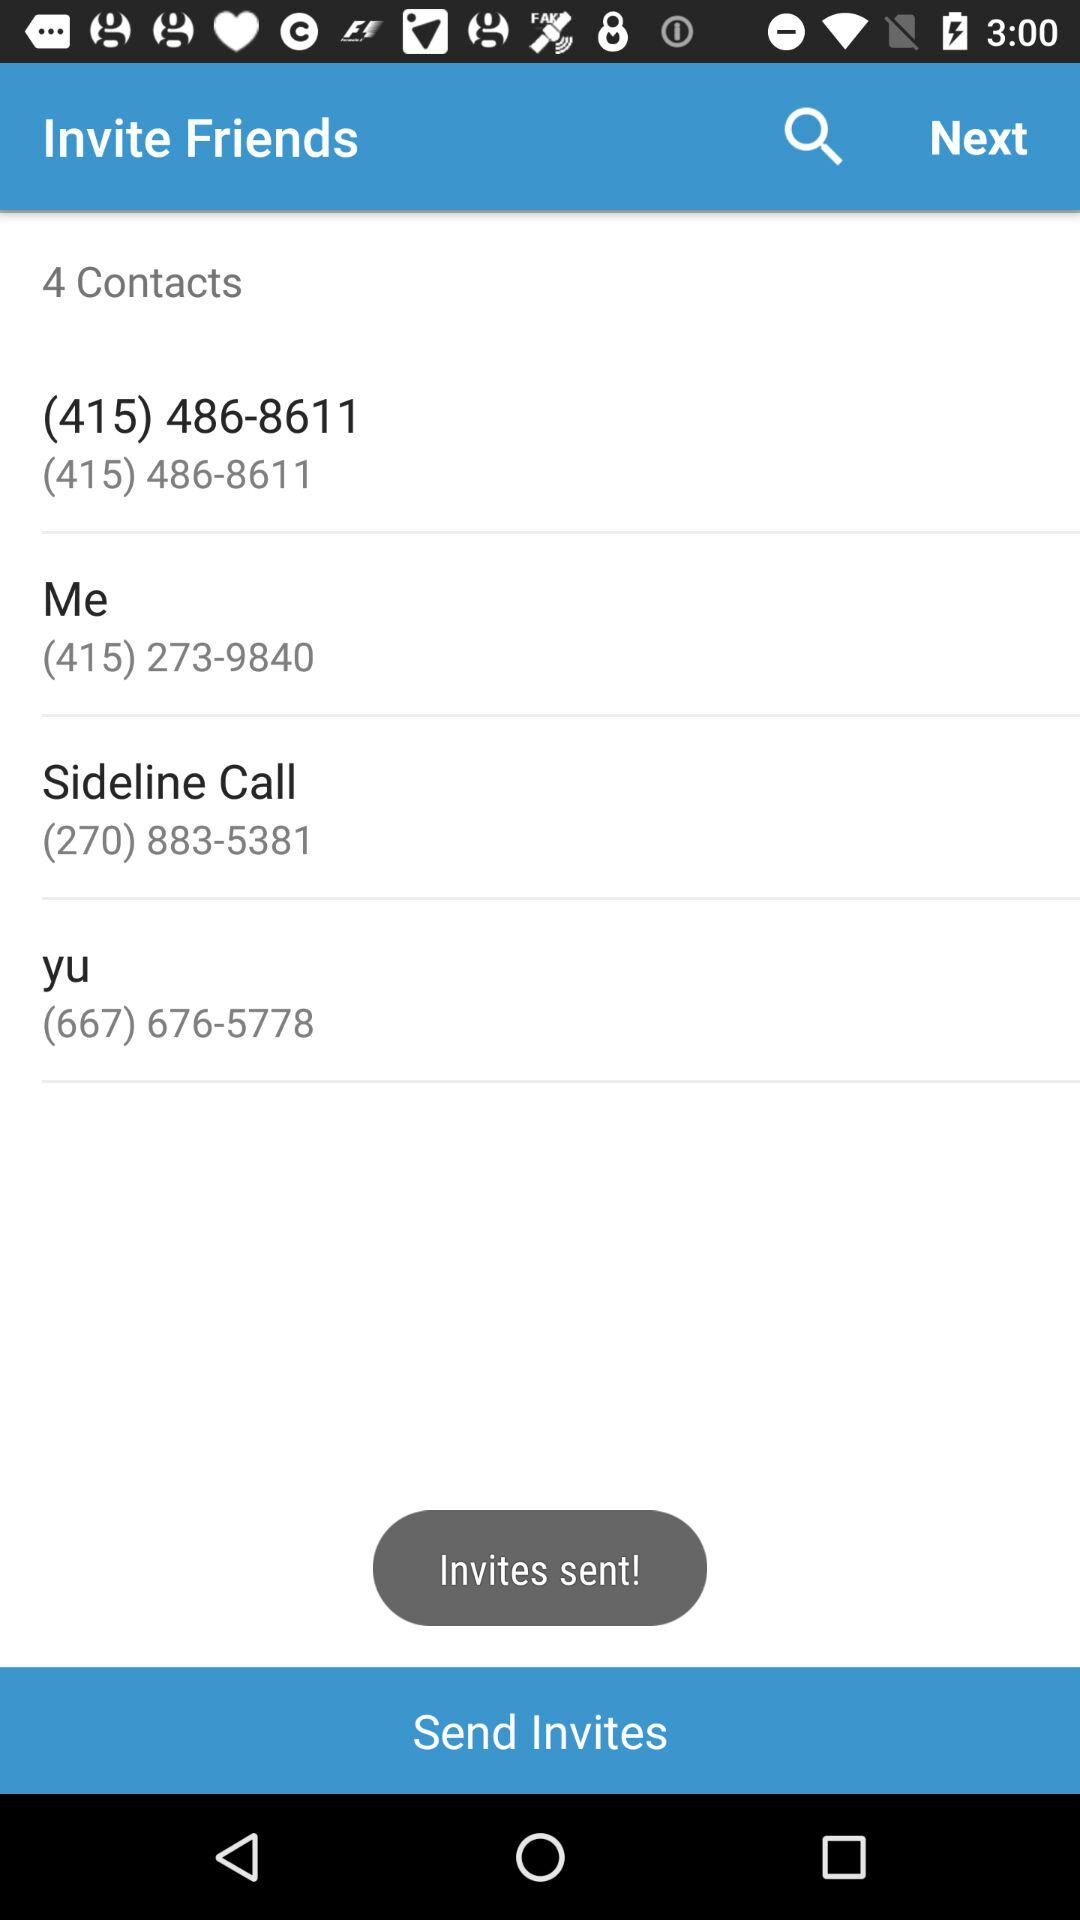What is the contact number of Yu? The contact number is (667) 676-5778. 